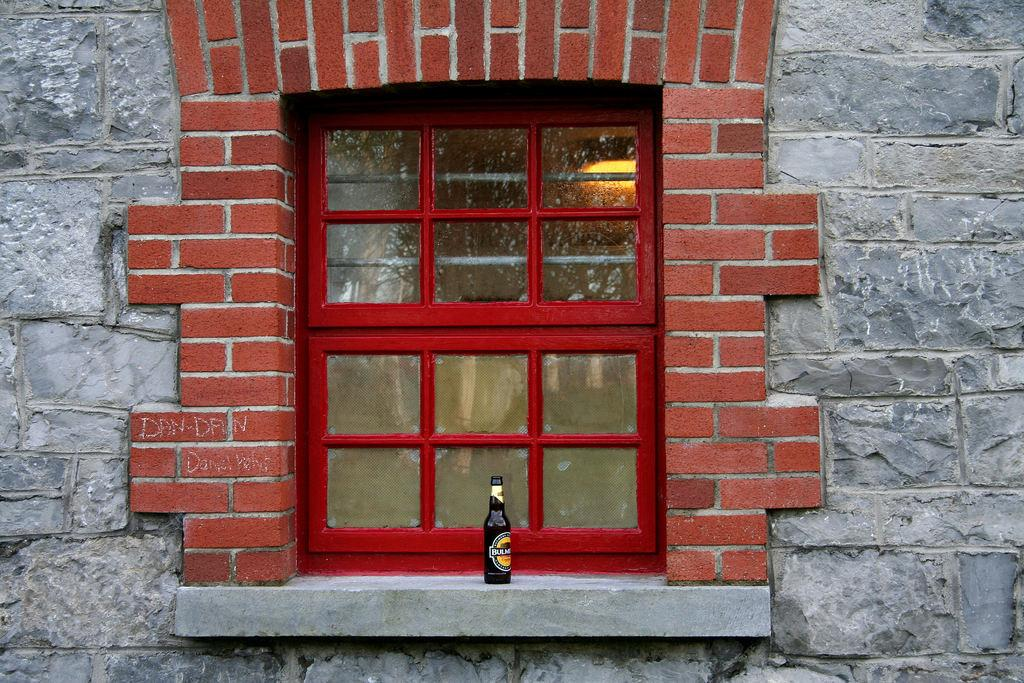What object is attached to the wall in the image? There is a beverage bottle on the wall in the image. What can be seen through the windows in the image? The presence of windows suggests that there is a view or outdoor scenery visible, but the specifics are not mentioned in the provided facts. What type of wall is featured in the image? There is a wall built with cobblestones in the image. What type of paper is being used to make peace in the image? There is no paper or reference to peace in the image; it features a beverage bottle on the wall, windows, and a cobblestone wall. 